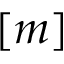Convert formula to latex. <formula><loc_0><loc_0><loc_500><loc_500>[ m ]</formula> 